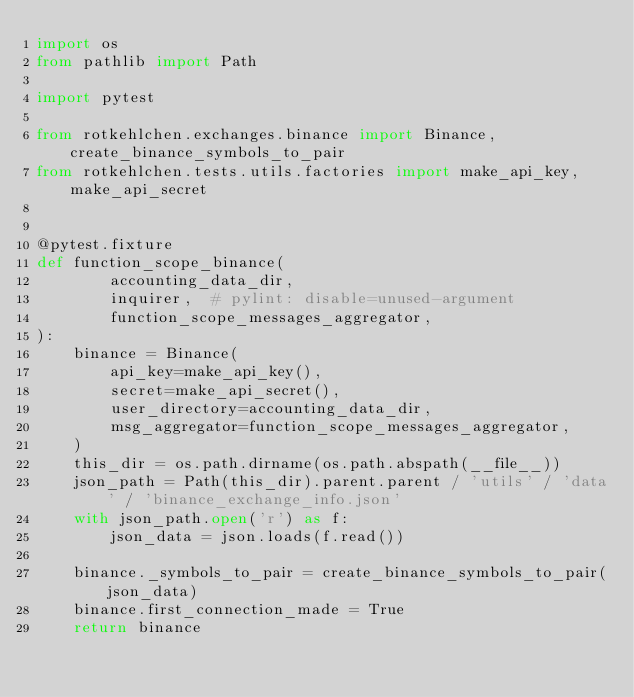Convert code to text. <code><loc_0><loc_0><loc_500><loc_500><_Python_>import os
from pathlib import Path

import pytest

from rotkehlchen.exchanges.binance import Binance, create_binance_symbols_to_pair
from rotkehlchen.tests.utils.factories import make_api_key, make_api_secret


@pytest.fixture
def function_scope_binance(
        accounting_data_dir,
        inquirer,  # pylint: disable=unused-argument
        function_scope_messages_aggregator,
):
    binance = Binance(
        api_key=make_api_key(),
        secret=make_api_secret(),
        user_directory=accounting_data_dir,
        msg_aggregator=function_scope_messages_aggregator,
    )
    this_dir = os.path.dirname(os.path.abspath(__file__))
    json_path = Path(this_dir).parent.parent / 'utils' / 'data' / 'binance_exchange_info.json'
    with json_path.open('r') as f:
        json_data = json.loads(f.read())

    binance._symbols_to_pair = create_binance_symbols_to_pair(json_data)
    binance.first_connection_made = True
    return binance
</code> 